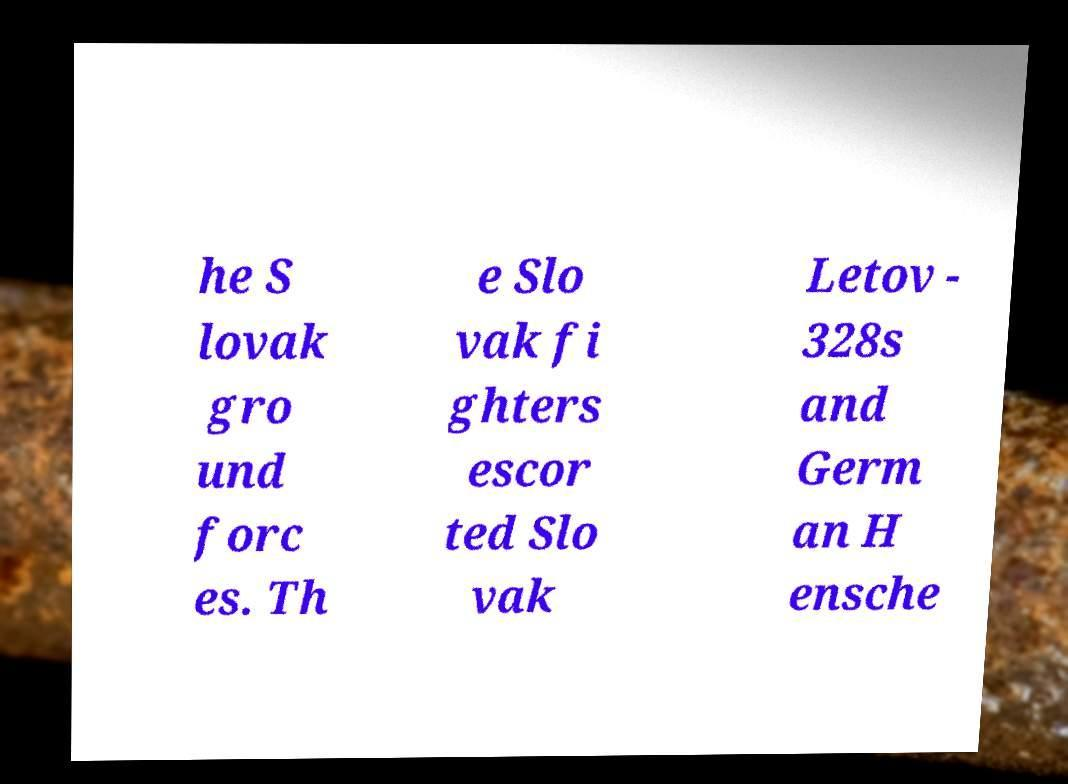Can you accurately transcribe the text from the provided image for me? he S lovak gro und forc es. Th e Slo vak fi ghters escor ted Slo vak Letov - 328s and Germ an H ensche 